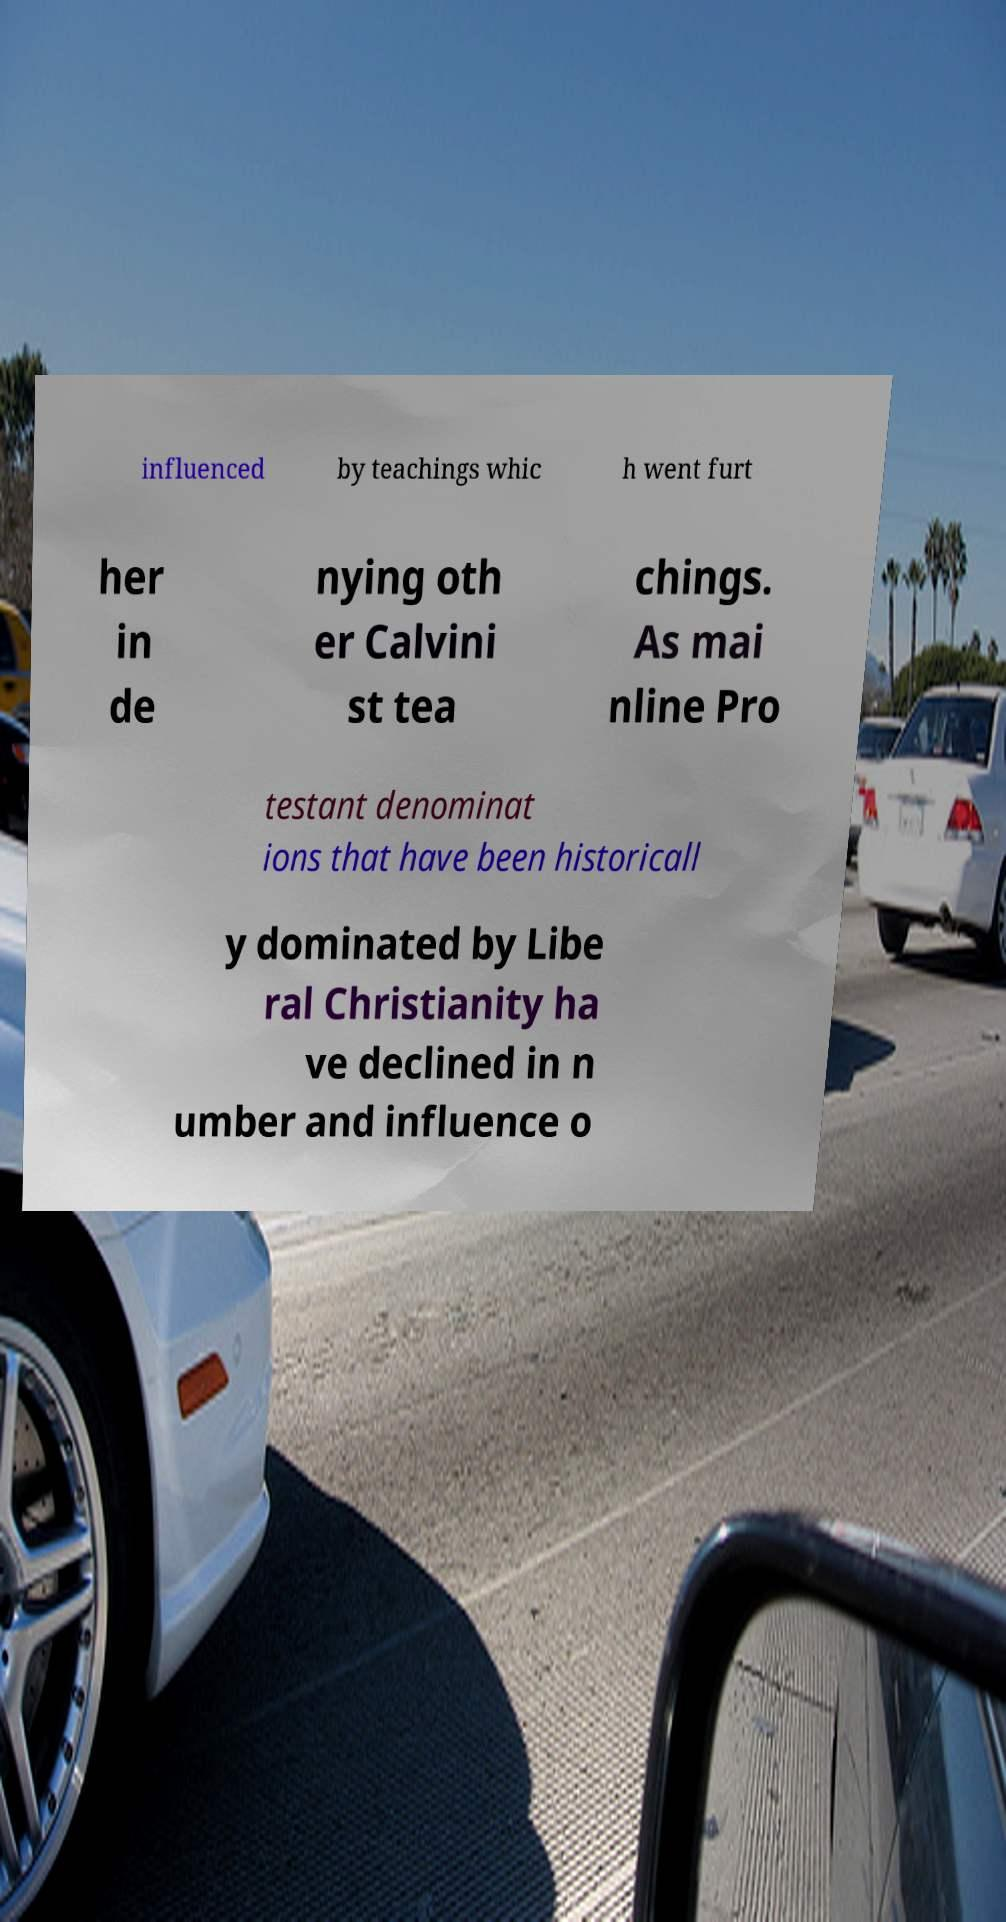Could you assist in decoding the text presented in this image and type it out clearly? influenced by teachings whic h went furt her in de nying oth er Calvini st tea chings. As mai nline Pro testant denominat ions that have been historicall y dominated by Libe ral Christianity ha ve declined in n umber and influence o 